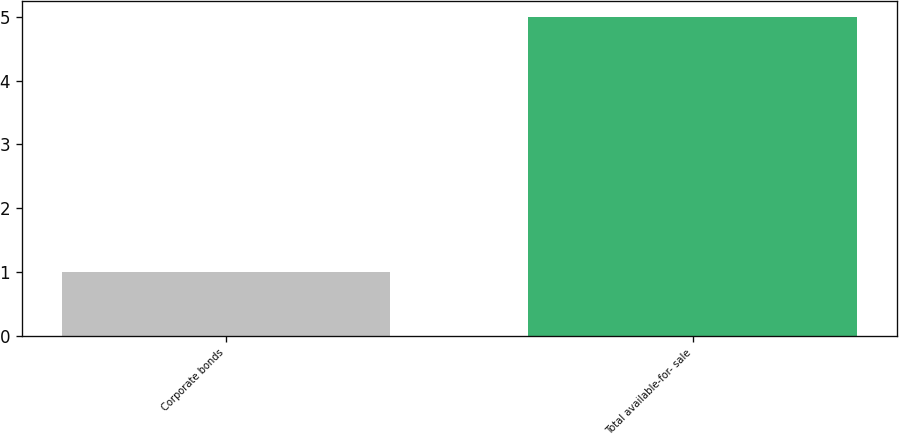Convert chart to OTSL. <chart><loc_0><loc_0><loc_500><loc_500><bar_chart><fcel>Corporate bonds<fcel>Total available-for- sale<nl><fcel>1<fcel>5<nl></chart> 